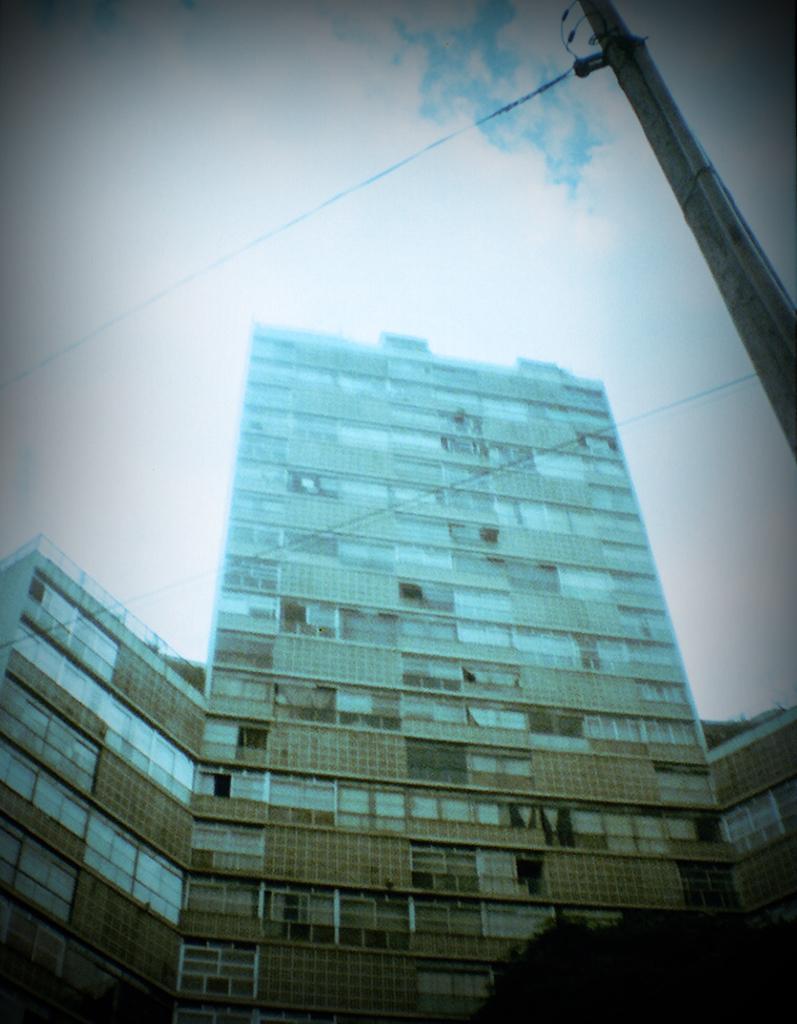Please provide a concise description of this image. In this image we can see buildings, trees, electric pole, electric cables and sky with clouds in the background. 